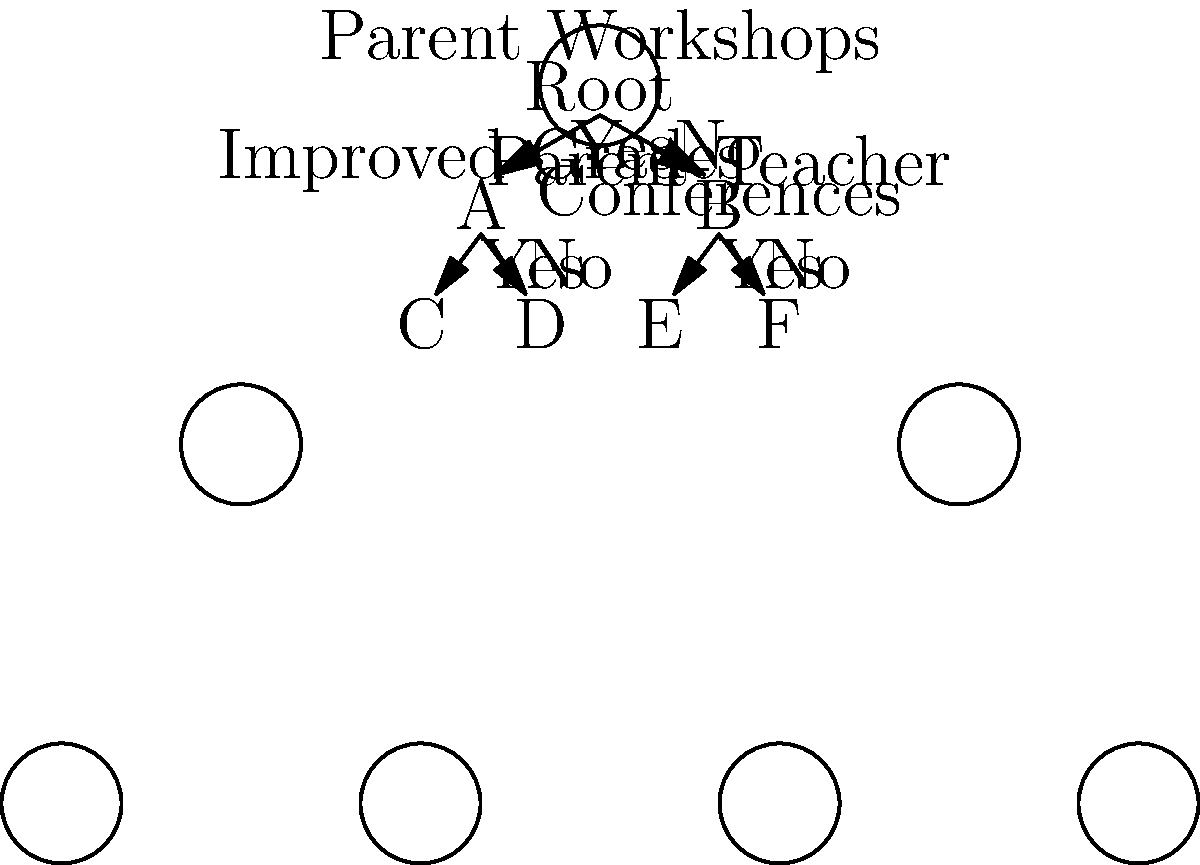Based on the decision tree diagram, which parent involvement strategy is predicted to have the most positive impact on student performance if both strategies are implemented and lead to positive outcomes? To answer this question, we need to analyze the decision tree diagram step by step:

1. The root node represents "Parent Workshops," which is the first decision point.

2. If we follow the "Yes" branch from the root (implementing parent workshops):
   a. We reach node A, which represents "Improved Grades."
   b. If we follow the "Yes" branch from A, we reach node C, which represents the best outcome in this branch.

3. If we follow the "No" branch from the root (not implementing parent workshops):
   a. We reach node B, which represents "Parent-Teacher Conferences."
   b. If we follow the "Yes" branch from B, we reach node E, which represents the best outcome in this branch.

4. To determine which strategy has the most positive impact when both are implemented:
   a. We need to compare the outcomes of implementing both strategies (node C) with implementing only one strategy (nodes D and E).
   b. Since node C is at the end of two "Yes" branches (for both parent workshops and improved grades), it represents the outcome of implementing both strategies successfully.

5. The position of node C at the leftmost leaf of the tree suggests that it represents the most positive outcome in terms of student performance.

Therefore, implementing both parent workshops and achieving improved grades (which likely results from increased parent involvement) is predicted to have the most positive impact on student performance according to this decision tree.
Answer: Implementing both parent workshops and achieving improved grades 